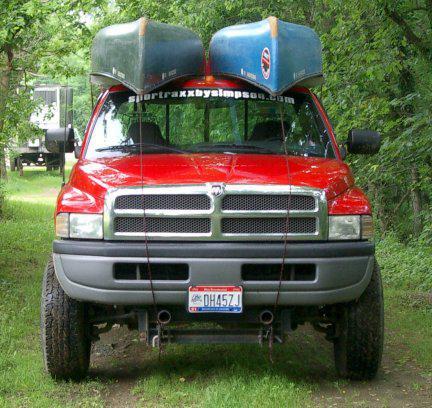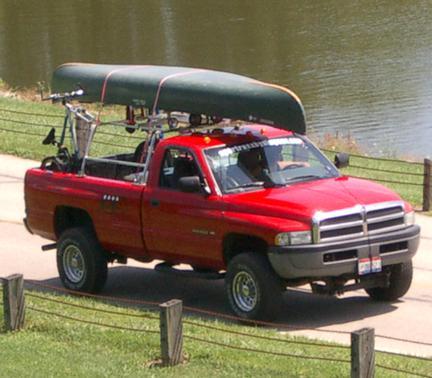The first image is the image on the left, the second image is the image on the right. For the images shown, is this caption "The left image contains one red truck." true? Answer yes or no. Yes. The first image is the image on the left, the second image is the image on the right. For the images displayed, is the sentence "In one image, a pickup truck near a body of water has one canoe loaded on a roof rack, while a second image shows a pickup truck near a green woody area with two canoes loaded overhead." factually correct? Answer yes or no. Yes. 